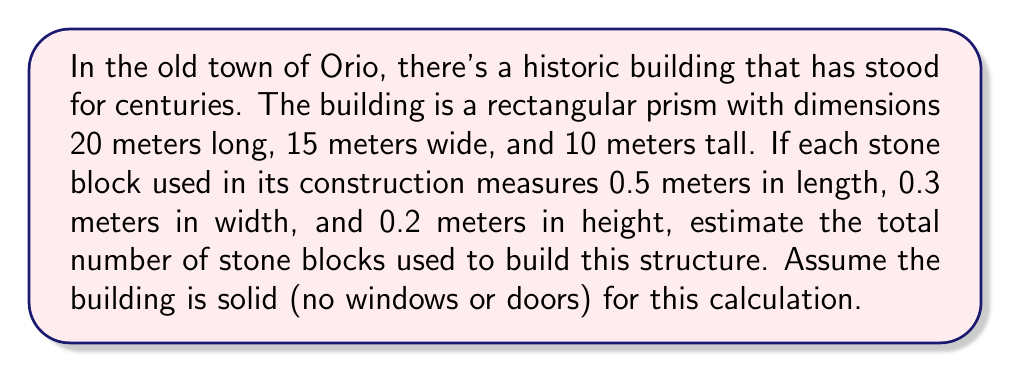Can you answer this question? Let's approach this problem step-by-step:

1) First, we need to calculate the volume of the entire building:
   $$V_{building} = 20 \text{ m} \times 15 \text{ m} \times 10 \text{ m} = 3000 \text{ m}^3$$

2) Next, we calculate the volume of a single stone block:
   $$V_{block} = 0.5 \text{ m} \times 0.3 \text{ m} \times 0.2 \text{ m} = 0.03 \text{ m}^3$$

3) To find the number of blocks, we divide the volume of the building by the volume of a single block:
   $$N_{blocks} = \frac{V_{building}}{V_{block}} = \frac{3000 \text{ m}^3}{0.03 \text{ m}^3} = 100,000$$

Therefore, approximately 100,000 stone blocks were used to construct this building.

Note: This is an estimate because:
- We've assumed the building is completely solid with no windows, doors, or internal spaces.
- We haven't accounted for mortar between the stones.
- In reality, some stones might have been cut to fit specific spaces, especially at the edges.
Answer: Approximately 100,000 stone blocks 